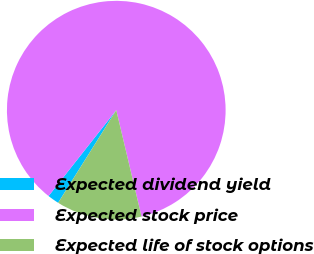Convert chart to OTSL. <chart><loc_0><loc_0><loc_500><loc_500><pie_chart><fcel>Expected dividend yield<fcel>Expected stock price<fcel>Expected life of stock options<nl><fcel>1.71%<fcel>85.65%<fcel>12.63%<nl></chart> 